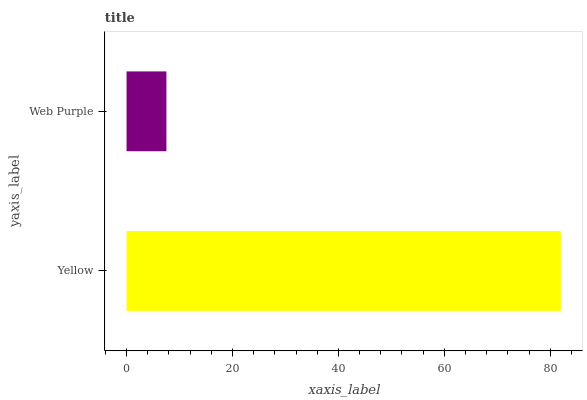Is Web Purple the minimum?
Answer yes or no. Yes. Is Yellow the maximum?
Answer yes or no. Yes. Is Web Purple the maximum?
Answer yes or no. No. Is Yellow greater than Web Purple?
Answer yes or no. Yes. Is Web Purple less than Yellow?
Answer yes or no. Yes. Is Web Purple greater than Yellow?
Answer yes or no. No. Is Yellow less than Web Purple?
Answer yes or no. No. Is Yellow the high median?
Answer yes or no. Yes. Is Web Purple the low median?
Answer yes or no. Yes. Is Web Purple the high median?
Answer yes or no. No. Is Yellow the low median?
Answer yes or no. No. 